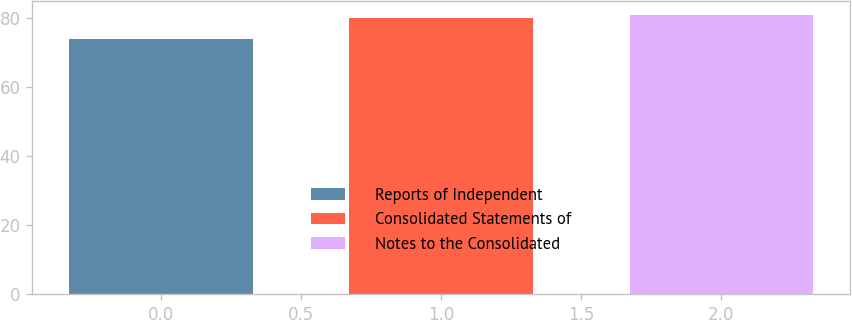Convert chart to OTSL. <chart><loc_0><loc_0><loc_500><loc_500><bar_chart><fcel>Reports of Independent<fcel>Consolidated Statements of<fcel>Notes to the Consolidated<nl><fcel>74<fcel>80<fcel>81<nl></chart> 